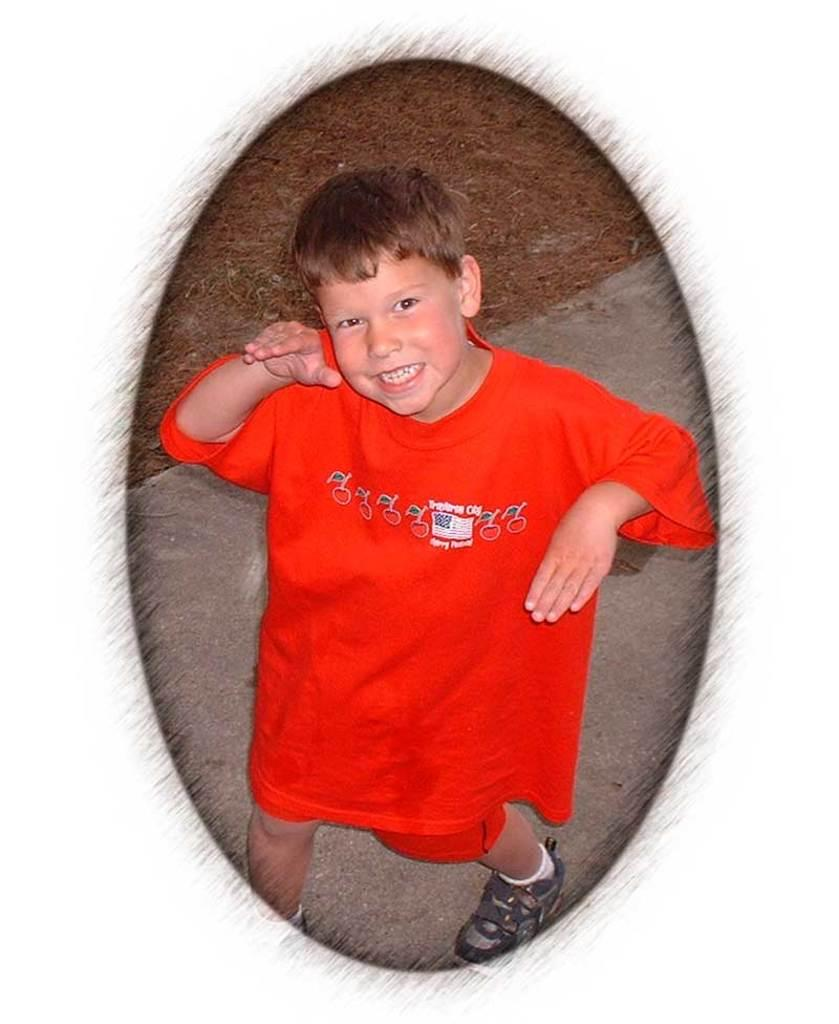Who is the main subject in the image? There is a boy in the image. What is the boy wearing? The boy is wearing a red dress. What expression does the boy have on his face? The boy has a smiling face. What activity is the boy engaged in? The boy is dancing on the road. What type of vegetation can be seen on the ground in the image? There is dried grass on the ground in the image. What does the mother of the boy say about his dancing in the image? There is no mention of the boy's mother or her opinion in the image. What type of territory does the boy claim by dancing on the road? The image does not suggest that the boy is claiming any territory by dancing on the road. 